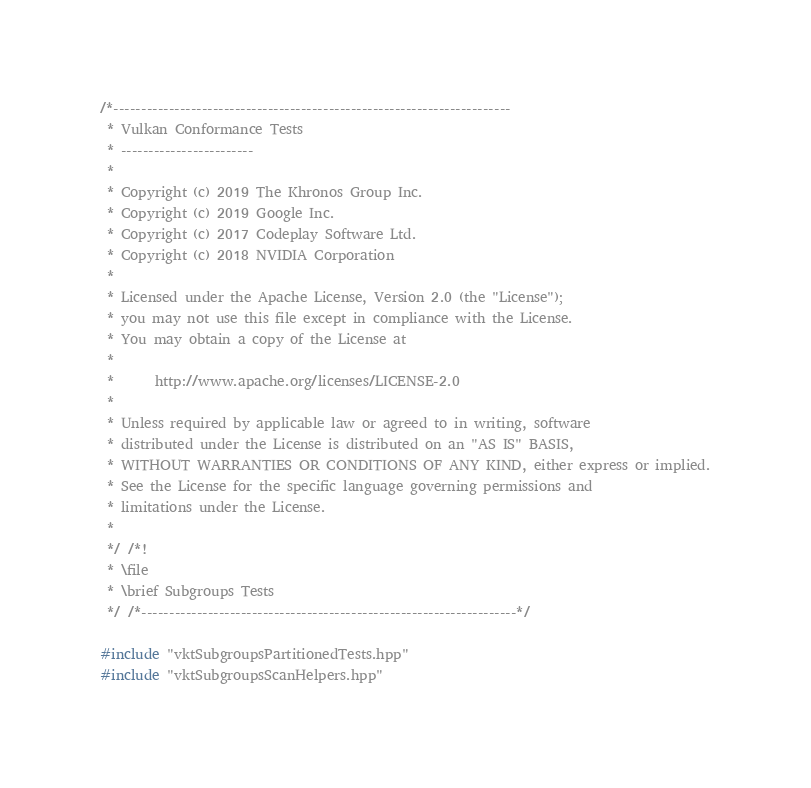Convert code to text. <code><loc_0><loc_0><loc_500><loc_500><_C++_>/*------------------------------------------------------------------------
 * Vulkan Conformance Tests
 * ------------------------
 *
 * Copyright (c) 2019 The Khronos Group Inc.
 * Copyright (c) 2019 Google Inc.
 * Copyright (c) 2017 Codeplay Software Ltd.
 * Copyright (c) 2018 NVIDIA Corporation
 *
 * Licensed under the Apache License, Version 2.0 (the "License");
 * you may not use this file except in compliance with the License.
 * You may obtain a copy of the License at
 *
 *      http://www.apache.org/licenses/LICENSE-2.0
 *
 * Unless required by applicable law or agreed to in writing, software
 * distributed under the License is distributed on an "AS IS" BASIS,
 * WITHOUT WARRANTIES OR CONDITIONS OF ANY KIND, either express or implied.
 * See the License for the specific language governing permissions and
 * limitations under the License.
 *
 */ /*!
 * \file
 * \brief Subgroups Tests
 */ /*--------------------------------------------------------------------*/

#include "vktSubgroupsPartitionedTests.hpp"
#include "vktSubgroupsScanHelpers.hpp"</code> 